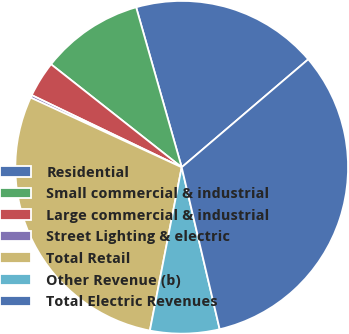<chart> <loc_0><loc_0><loc_500><loc_500><pie_chart><fcel>Residential<fcel>Small commercial & industrial<fcel>Large commercial & industrial<fcel>Street Lighting & electric<fcel>Total Retail<fcel>Other Revenue (b)<fcel>Total Electric Revenues<nl><fcel>18.17%<fcel>9.96%<fcel>3.49%<fcel>0.26%<fcel>28.81%<fcel>6.73%<fcel>32.57%<nl></chart> 